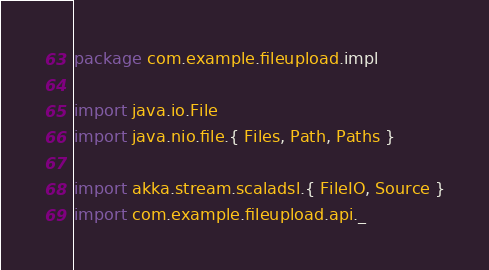Convert code to text. <code><loc_0><loc_0><loc_500><loc_500><_Scala_>package com.example.fileupload.impl

import java.io.File
import java.nio.file.{ Files, Path, Paths }

import akka.stream.scaladsl.{ FileIO, Source }
import com.example.fileupload.api._</code> 